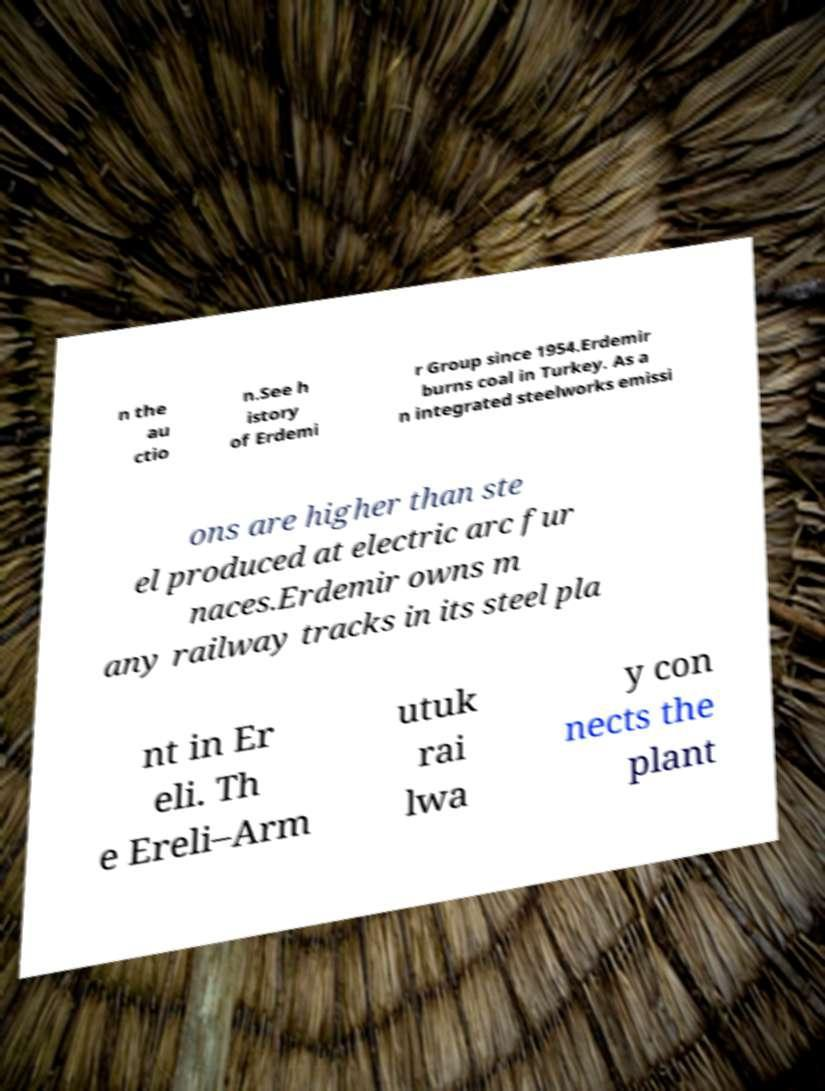I need the written content from this picture converted into text. Can you do that? n the au ctio n.See h istory of Erdemi r Group since 1954.Erdemir burns coal in Turkey. As a n integrated steelworks emissi ons are higher than ste el produced at electric arc fur naces.Erdemir owns m any railway tracks in its steel pla nt in Er eli. Th e Ereli–Arm utuk rai lwa y con nects the plant 